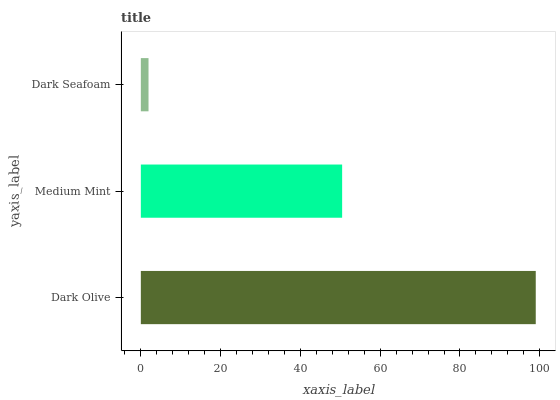Is Dark Seafoam the minimum?
Answer yes or no. Yes. Is Dark Olive the maximum?
Answer yes or no. Yes. Is Medium Mint the minimum?
Answer yes or no. No. Is Medium Mint the maximum?
Answer yes or no. No. Is Dark Olive greater than Medium Mint?
Answer yes or no. Yes. Is Medium Mint less than Dark Olive?
Answer yes or no. Yes. Is Medium Mint greater than Dark Olive?
Answer yes or no. No. Is Dark Olive less than Medium Mint?
Answer yes or no. No. Is Medium Mint the high median?
Answer yes or no. Yes. Is Medium Mint the low median?
Answer yes or no. Yes. Is Dark Seafoam the high median?
Answer yes or no. No. Is Dark Seafoam the low median?
Answer yes or no. No. 